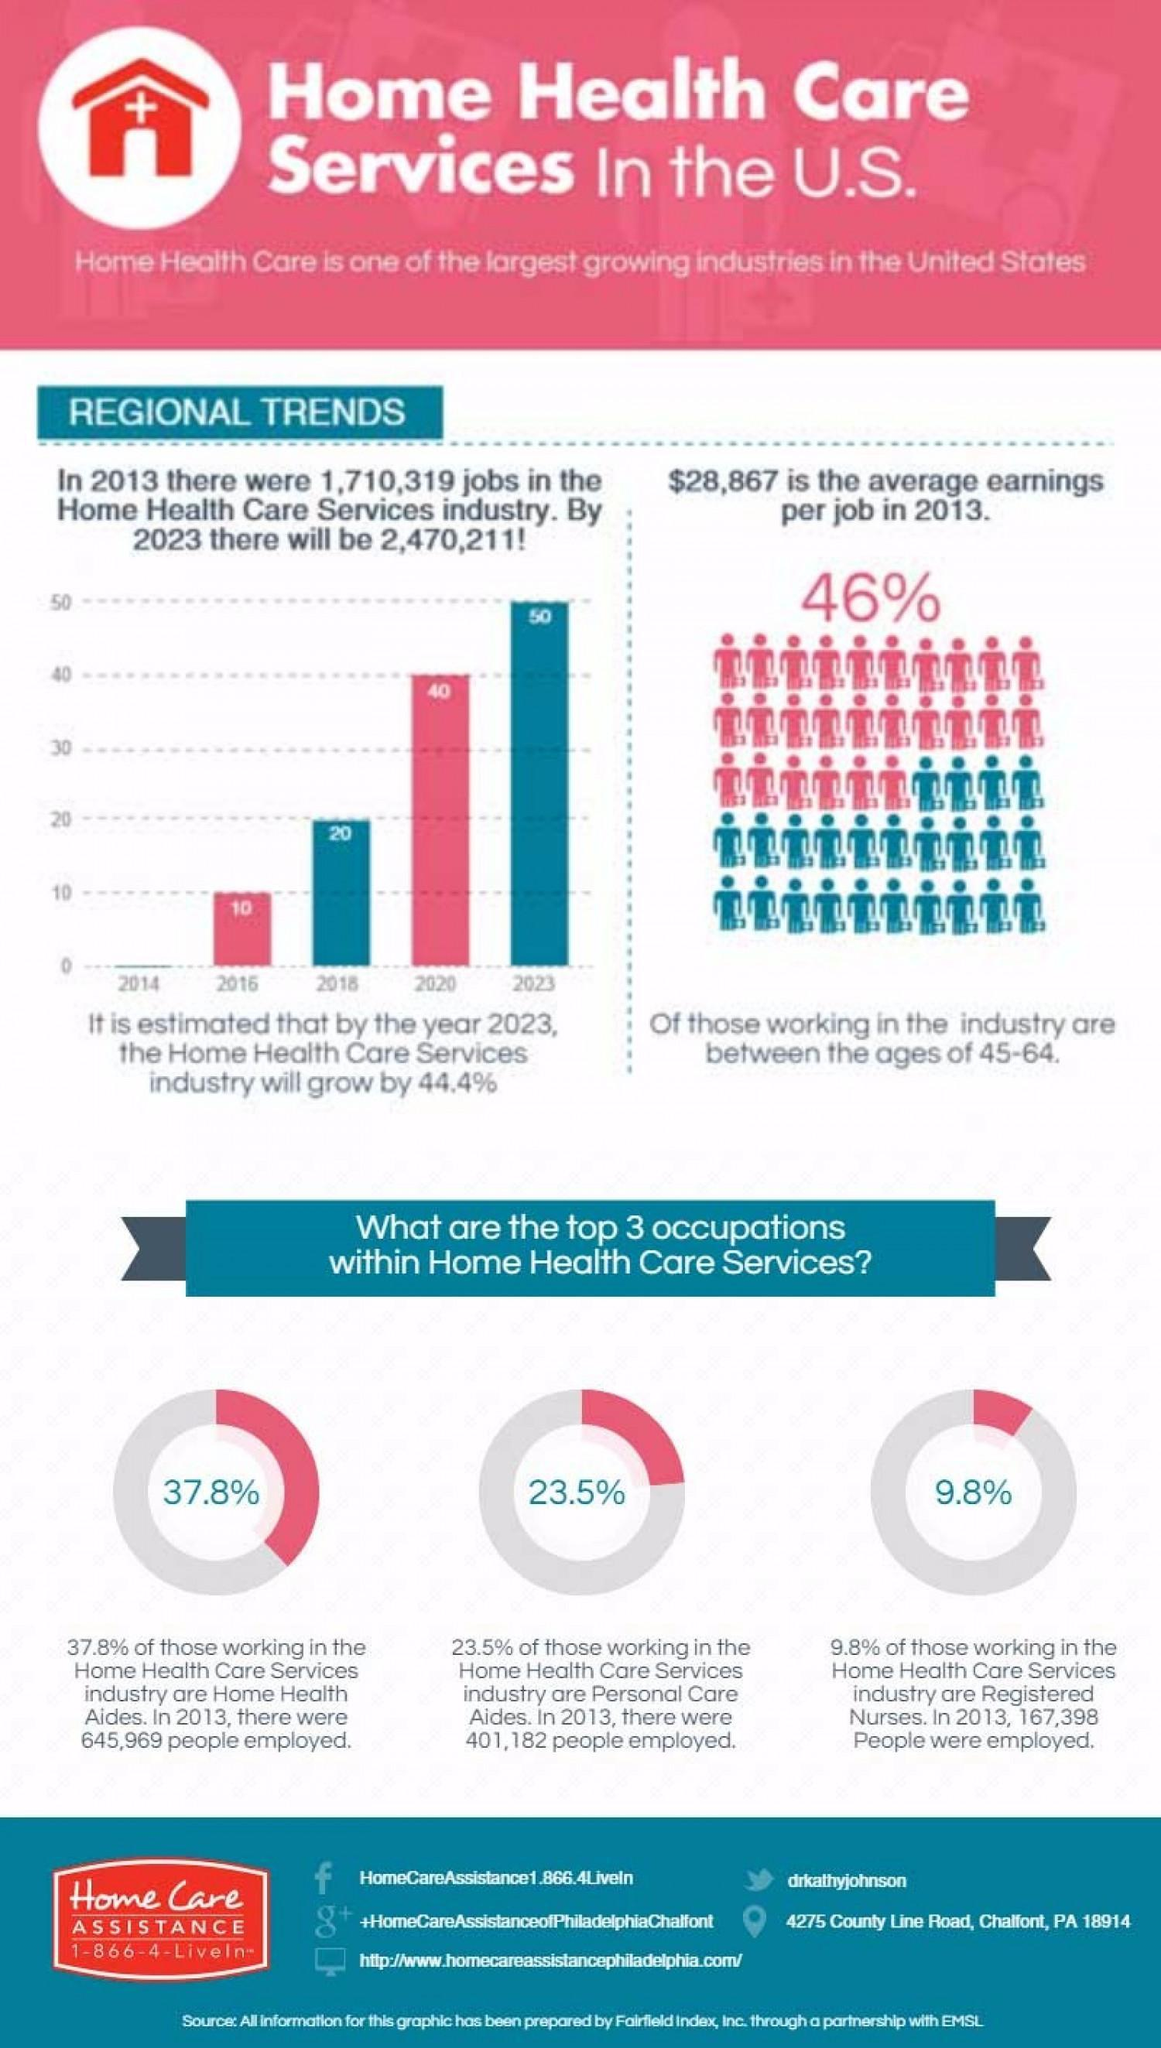what is the percentage of personal care aides
Answer the question with a short phrase. 23.5% what is the count of personal care aides in 2013 401,182 what is the expected jobs in health care services 10 years from 2013 2,470,211 what is facebook address HomeCareAssistance1.866.4LiveIn what is the twitter handle drkathyjohnson how many are the age group of 45-64 46% 